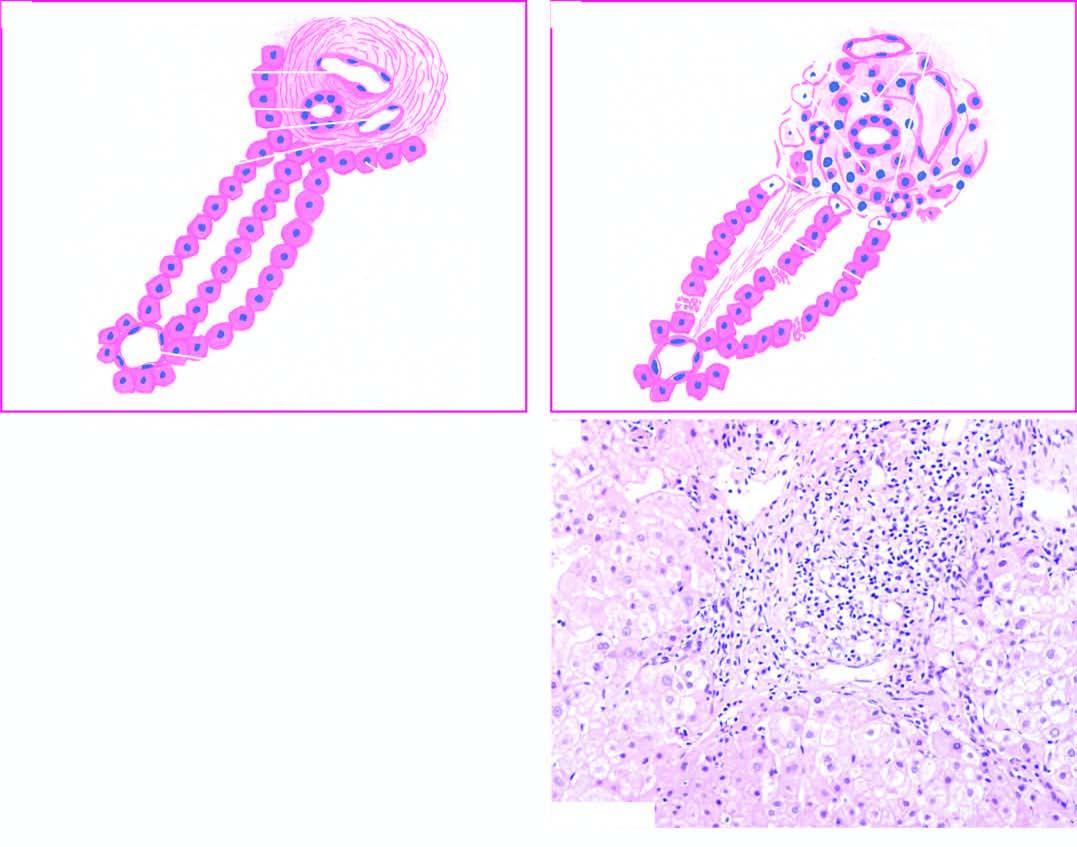does photomicrograph on right show stellate-shaped portal triad, with extension of fibrous spurs into lobules?
Answer the question using a single word or phrase. Yes 